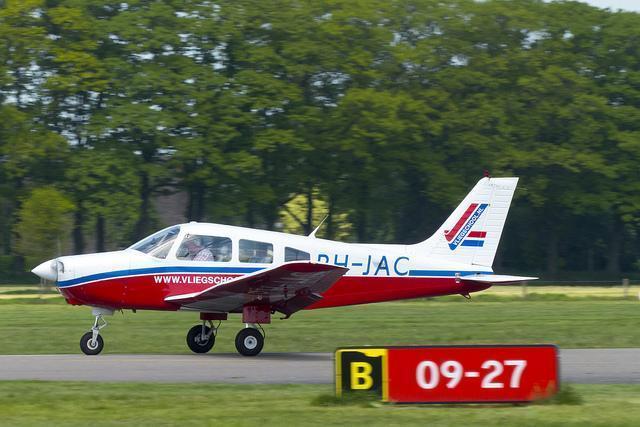How many wheels is on this plane?
Give a very brief answer. 3. How many sandwich on the plate?
Give a very brief answer. 0. 